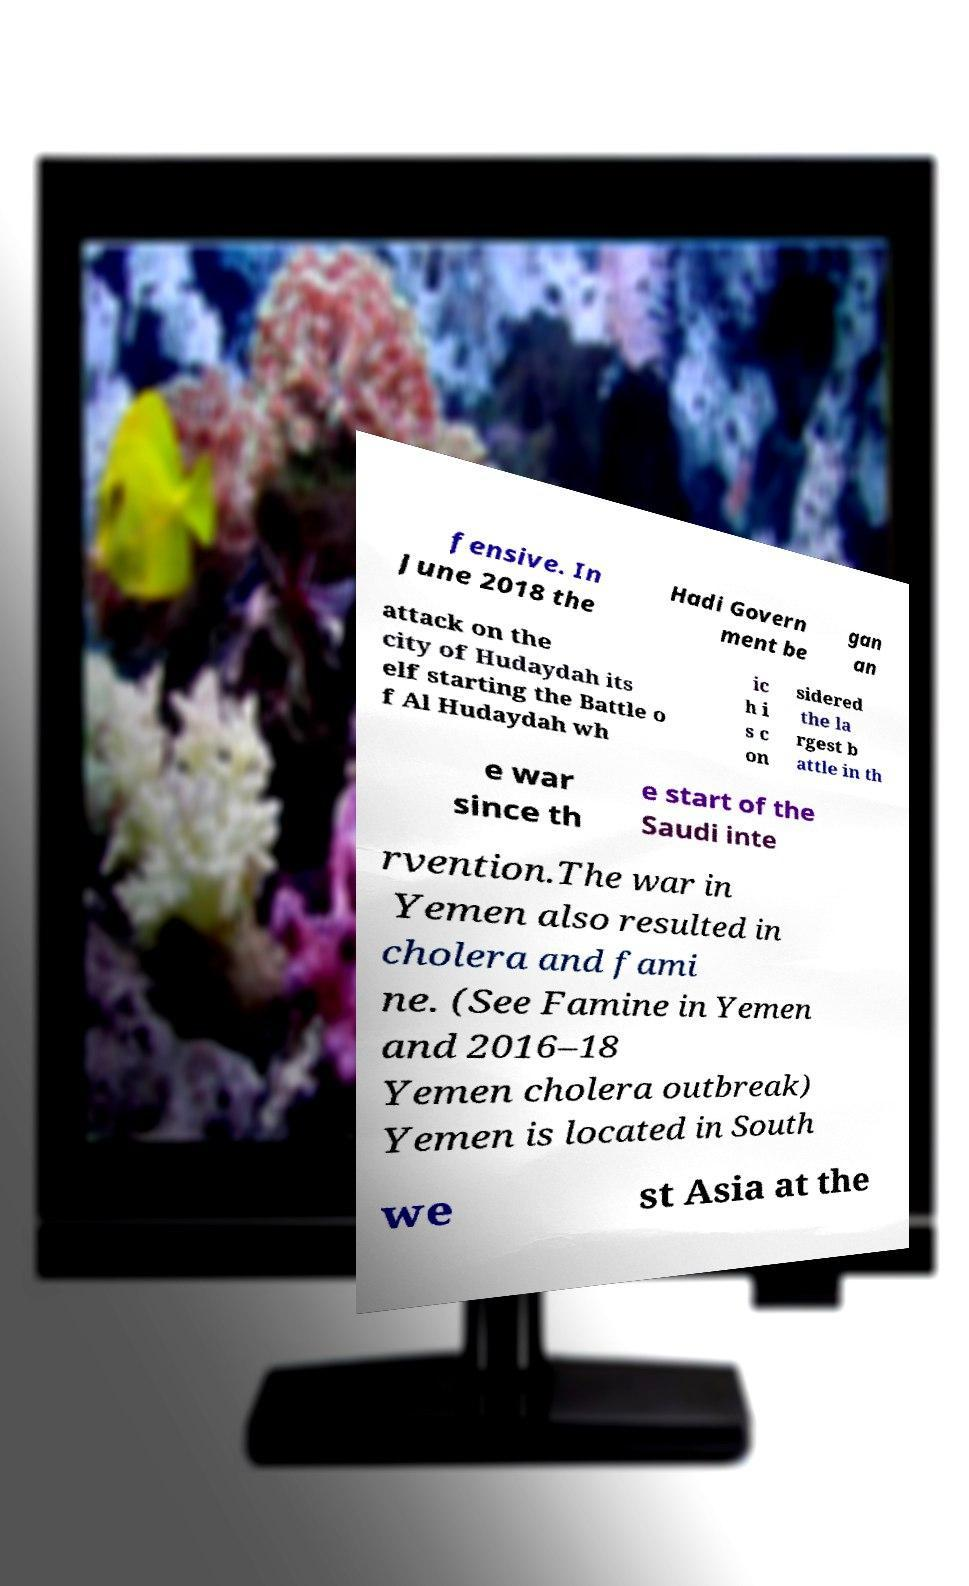Could you assist in decoding the text presented in this image and type it out clearly? fensive. In June 2018 the Hadi Govern ment be gan an attack on the city of Hudaydah its elf starting the Battle o f Al Hudaydah wh ic h i s c on sidered the la rgest b attle in th e war since th e start of the Saudi inte rvention.The war in Yemen also resulted in cholera and fami ne. (See Famine in Yemen and 2016–18 Yemen cholera outbreak) Yemen is located in South we st Asia at the 